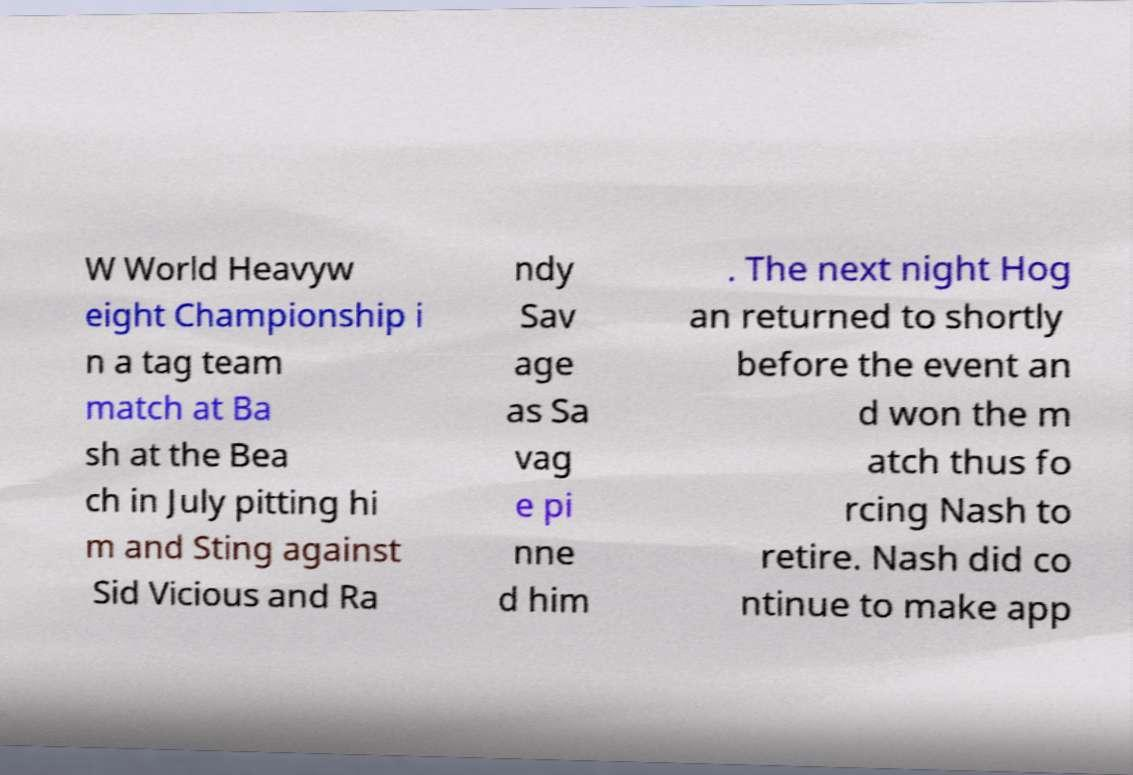Can you read and provide the text displayed in the image?This photo seems to have some interesting text. Can you extract and type it out for me? W World Heavyw eight Championship i n a tag team match at Ba sh at the Bea ch in July pitting hi m and Sting against Sid Vicious and Ra ndy Sav age as Sa vag e pi nne d him . The next night Hog an returned to shortly before the event an d won the m atch thus fo rcing Nash to retire. Nash did co ntinue to make app 